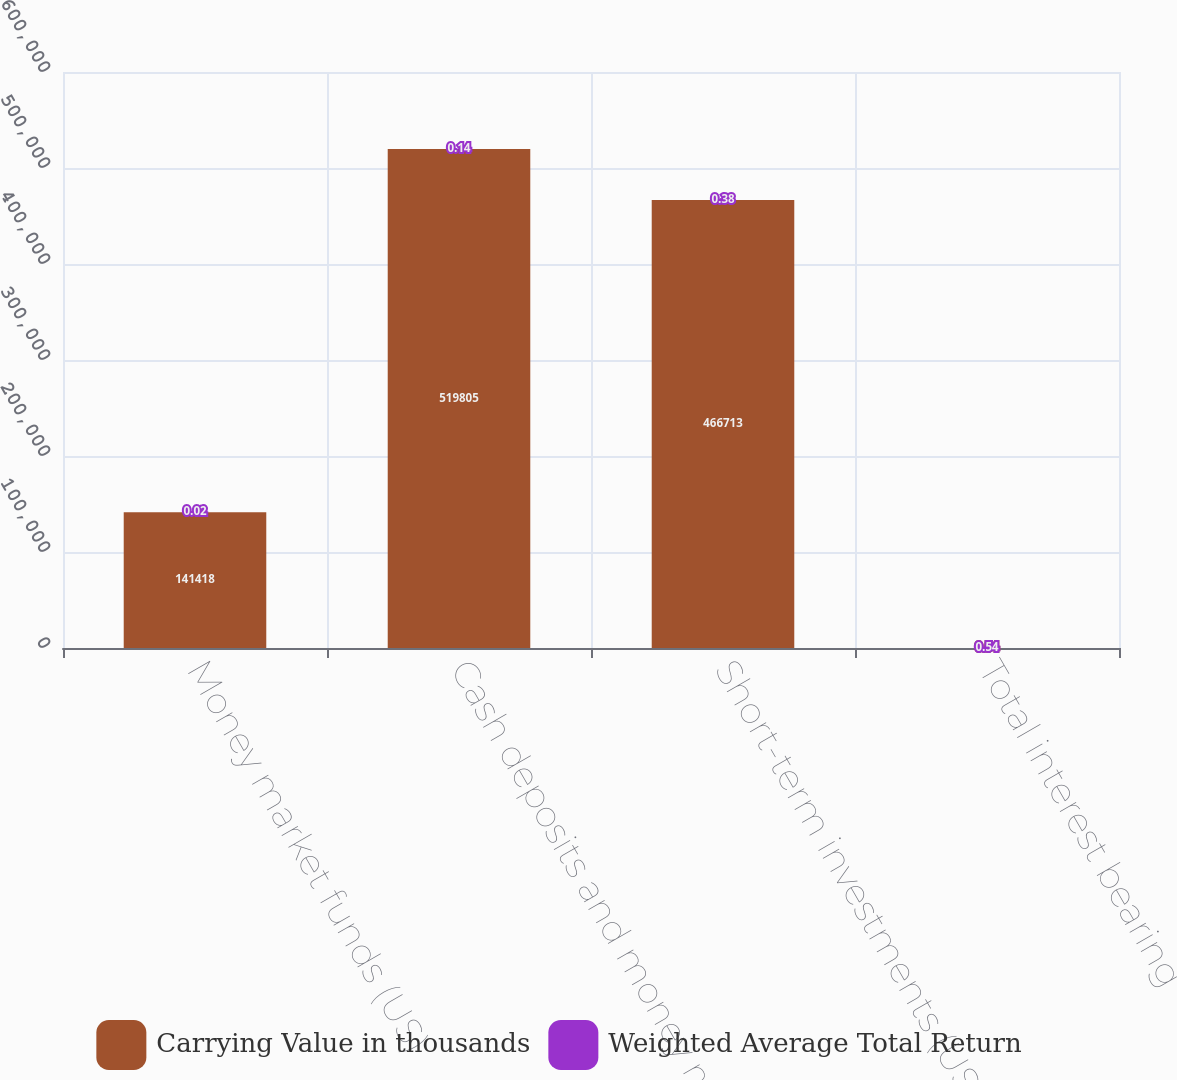Convert chart. <chart><loc_0><loc_0><loc_500><loc_500><stacked_bar_chart><ecel><fcel>Money market funds (US)<fcel>Cash deposits and money market<fcel>Short-term investments (US)<fcel>Total interest bearing<nl><fcel>Carrying Value in thousands<fcel>141418<fcel>519805<fcel>466713<fcel>0.54<nl><fcel>Weighted Average Total Return<fcel>0.02<fcel>0.14<fcel>0.38<fcel>0.54<nl></chart> 